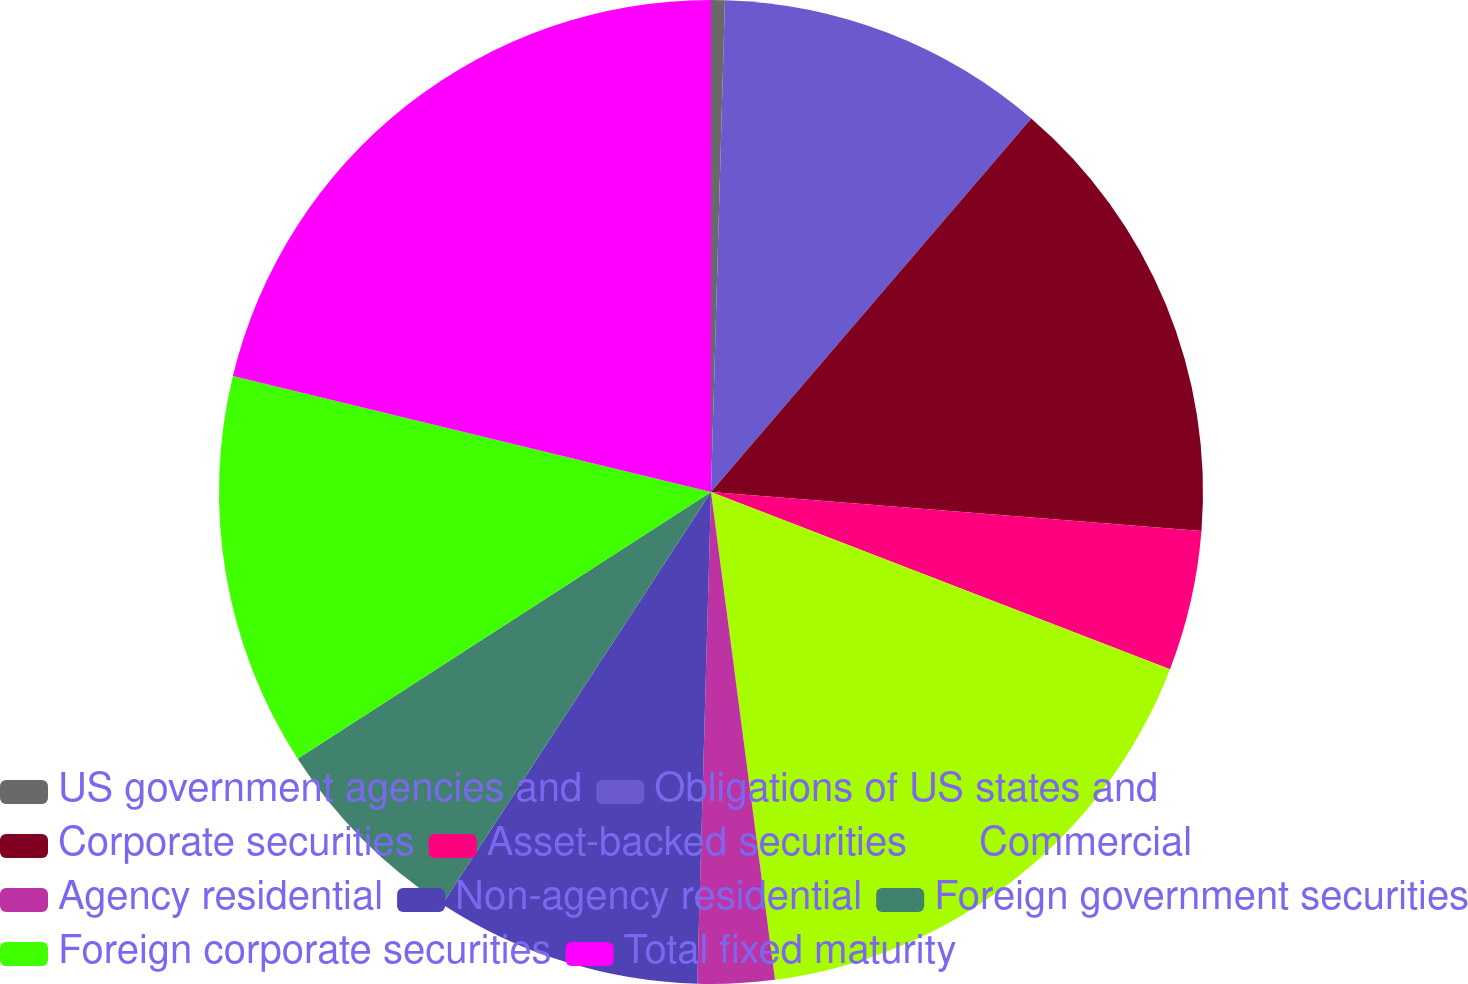Convert chart to OTSL. <chart><loc_0><loc_0><loc_500><loc_500><pie_chart><fcel>US government agencies and<fcel>Obligations of US states and<fcel>Corporate securities<fcel>Asset-backed securities<fcel>Commercial<fcel>Agency residential<fcel>Non-agency residential<fcel>Foreign government securities<fcel>Foreign corporate securities<fcel>Total fixed maturity<nl><fcel>0.45%<fcel>10.83%<fcel>14.98%<fcel>4.6%<fcel>17.06%<fcel>2.52%<fcel>8.75%<fcel>6.68%<fcel>12.91%<fcel>21.21%<nl></chart> 